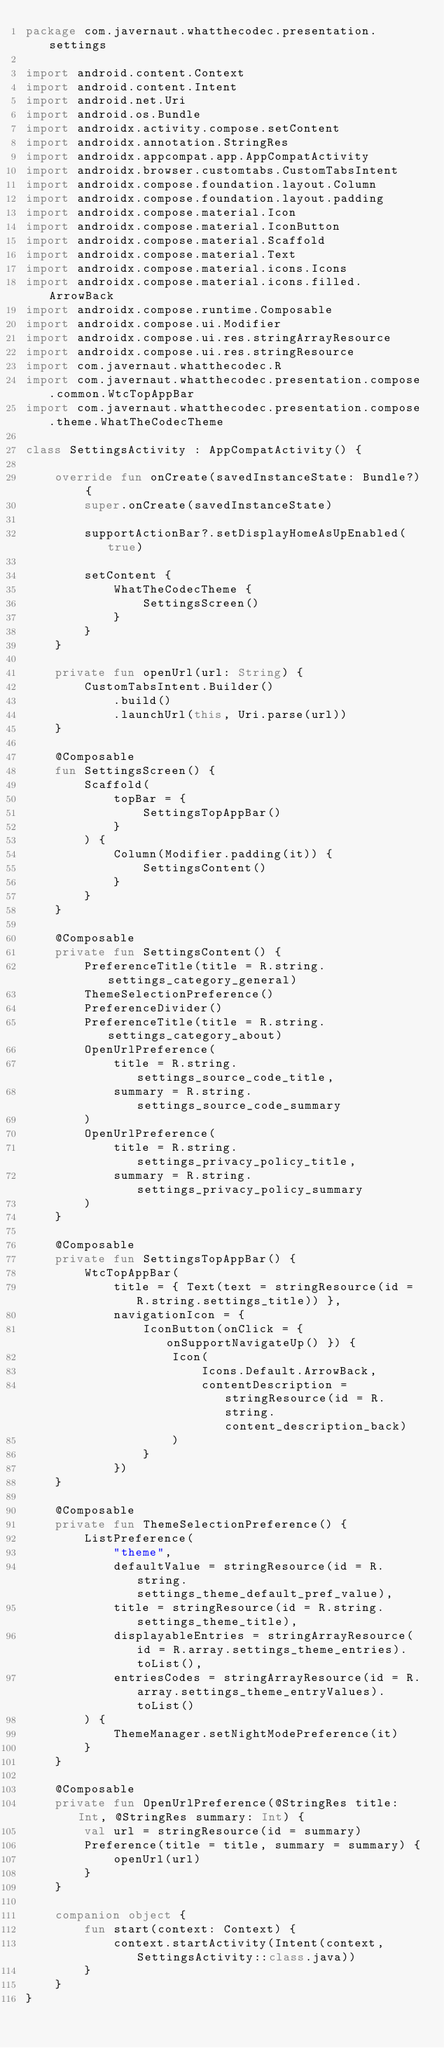<code> <loc_0><loc_0><loc_500><loc_500><_Kotlin_>package com.javernaut.whatthecodec.presentation.settings

import android.content.Context
import android.content.Intent
import android.net.Uri
import android.os.Bundle
import androidx.activity.compose.setContent
import androidx.annotation.StringRes
import androidx.appcompat.app.AppCompatActivity
import androidx.browser.customtabs.CustomTabsIntent
import androidx.compose.foundation.layout.Column
import androidx.compose.foundation.layout.padding
import androidx.compose.material.Icon
import androidx.compose.material.IconButton
import androidx.compose.material.Scaffold
import androidx.compose.material.Text
import androidx.compose.material.icons.Icons
import androidx.compose.material.icons.filled.ArrowBack
import androidx.compose.runtime.Composable
import androidx.compose.ui.Modifier
import androidx.compose.ui.res.stringArrayResource
import androidx.compose.ui.res.stringResource
import com.javernaut.whatthecodec.R
import com.javernaut.whatthecodec.presentation.compose.common.WtcTopAppBar
import com.javernaut.whatthecodec.presentation.compose.theme.WhatTheCodecTheme

class SettingsActivity : AppCompatActivity() {

    override fun onCreate(savedInstanceState: Bundle?) {
        super.onCreate(savedInstanceState)

        supportActionBar?.setDisplayHomeAsUpEnabled(true)

        setContent {
            WhatTheCodecTheme {
                SettingsScreen()
            }
        }
    }

    private fun openUrl(url: String) {
        CustomTabsIntent.Builder()
            .build()
            .launchUrl(this, Uri.parse(url))
    }

    @Composable
    fun SettingsScreen() {
        Scaffold(
            topBar = {
                SettingsTopAppBar()
            }
        ) {
            Column(Modifier.padding(it)) {
                SettingsContent()
            }
        }
    }

    @Composable
    private fun SettingsContent() {
        PreferenceTitle(title = R.string.settings_category_general)
        ThemeSelectionPreference()
        PreferenceDivider()
        PreferenceTitle(title = R.string.settings_category_about)
        OpenUrlPreference(
            title = R.string.settings_source_code_title,
            summary = R.string.settings_source_code_summary
        )
        OpenUrlPreference(
            title = R.string.settings_privacy_policy_title,
            summary = R.string.settings_privacy_policy_summary
        )
    }

    @Composable
    private fun SettingsTopAppBar() {
        WtcTopAppBar(
            title = { Text(text = stringResource(id = R.string.settings_title)) },
            navigationIcon = {
                IconButton(onClick = { onSupportNavigateUp() }) {
                    Icon(
                        Icons.Default.ArrowBack,
                        contentDescription = stringResource(id = R.string.content_description_back)
                    )
                }
            })
    }

    @Composable
    private fun ThemeSelectionPreference() {
        ListPreference(
            "theme",
            defaultValue = stringResource(id = R.string.settings_theme_default_pref_value),
            title = stringResource(id = R.string.settings_theme_title),
            displayableEntries = stringArrayResource(id = R.array.settings_theme_entries).toList(),
            entriesCodes = stringArrayResource(id = R.array.settings_theme_entryValues).toList()
        ) {
            ThemeManager.setNightModePreference(it)
        }
    }

    @Composable
    private fun OpenUrlPreference(@StringRes title: Int, @StringRes summary: Int) {
        val url = stringResource(id = summary)
        Preference(title = title, summary = summary) {
            openUrl(url)
        }
    }

    companion object {
        fun start(context: Context) {
            context.startActivity(Intent(context, SettingsActivity::class.java))
        }
    }
}
</code> 